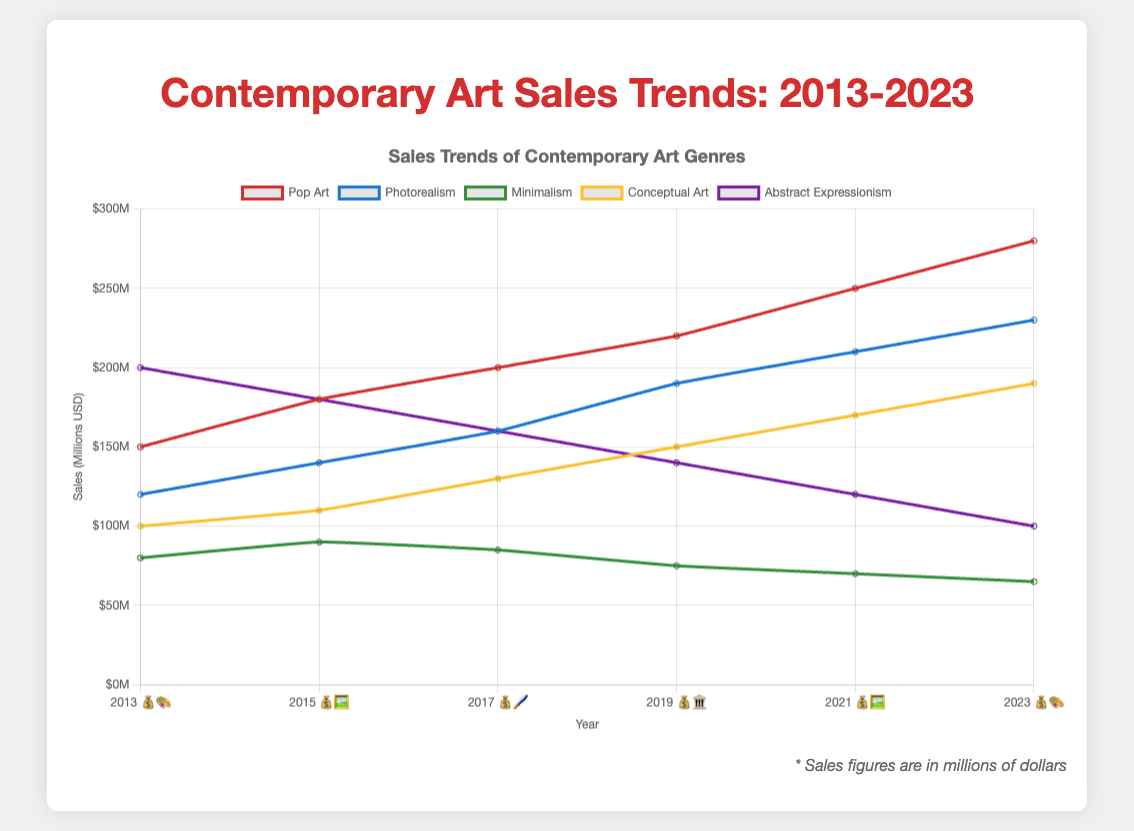What is the highest sales figure for Pop Art in the entire period? Look for the highest data point along the Pop Art line (which should be clearly labeled with a distinctive color). From the plot, it’s $280M in 2023.
Answer: $280M How does the sales trend of Abstract Expressionism change over time? Observe the sales values for Abstract Expressionism across different years and note the overall trend. The sales show a consistent decline from 2013 ($200M) to 2023 ($100M).
Answer: Decline Which year saw the highest sales for Photorealism? Look at the data points for Photorealism (in its specific color) and identify the highest value, which is 2023 with $230M.
Answer: 2023 Which genre had the lowest sales in 2019? Check the data points for all genres in 2019. Minimalism had the lowest sales at $75M.
Answer: Minimalism Compare sales for Conceptual Art and Pop Art in 2021. Which had higher sales and by how much? Find the data points for Conceptual Art and Pop Art in 2021. Pop Art had $250M, and Conceptual Art had $170M. The difference is $250M - $170M = $80M.
Answer: Pop Art, by $80M What was the average sales figure for Minimalism across all the years? Sum the values for Minimalism from 2013 to 2023 and then divide by the number of years: (80 + 90 + 85 + 75 + 70 + 65) / 6 = 77.5.
Answer: $77.5M Which year had the second-highest sales for Conceptual Art? Check the sales data points for Conceptual Art, identify the highest and then the second highest values. The second-highest is 2019 with $150M (after 2023 with $190M).
Answer: 2019 How did the sales for Abstract Expressionism change from 2013 to 2023? Compare the sales figures for Abstract Expressionism in 2013 ($200M) and 2023 ($100M). The sales decreased by $200M - $100M = $100M.
Answer: Decreased by $100M Which genre showed the most consistent sales trend over the decade? Examine the sales lines for each genre and note the one with the least fluctuation. Minimalism has the most consistent trend.
Answer: Minimalism 